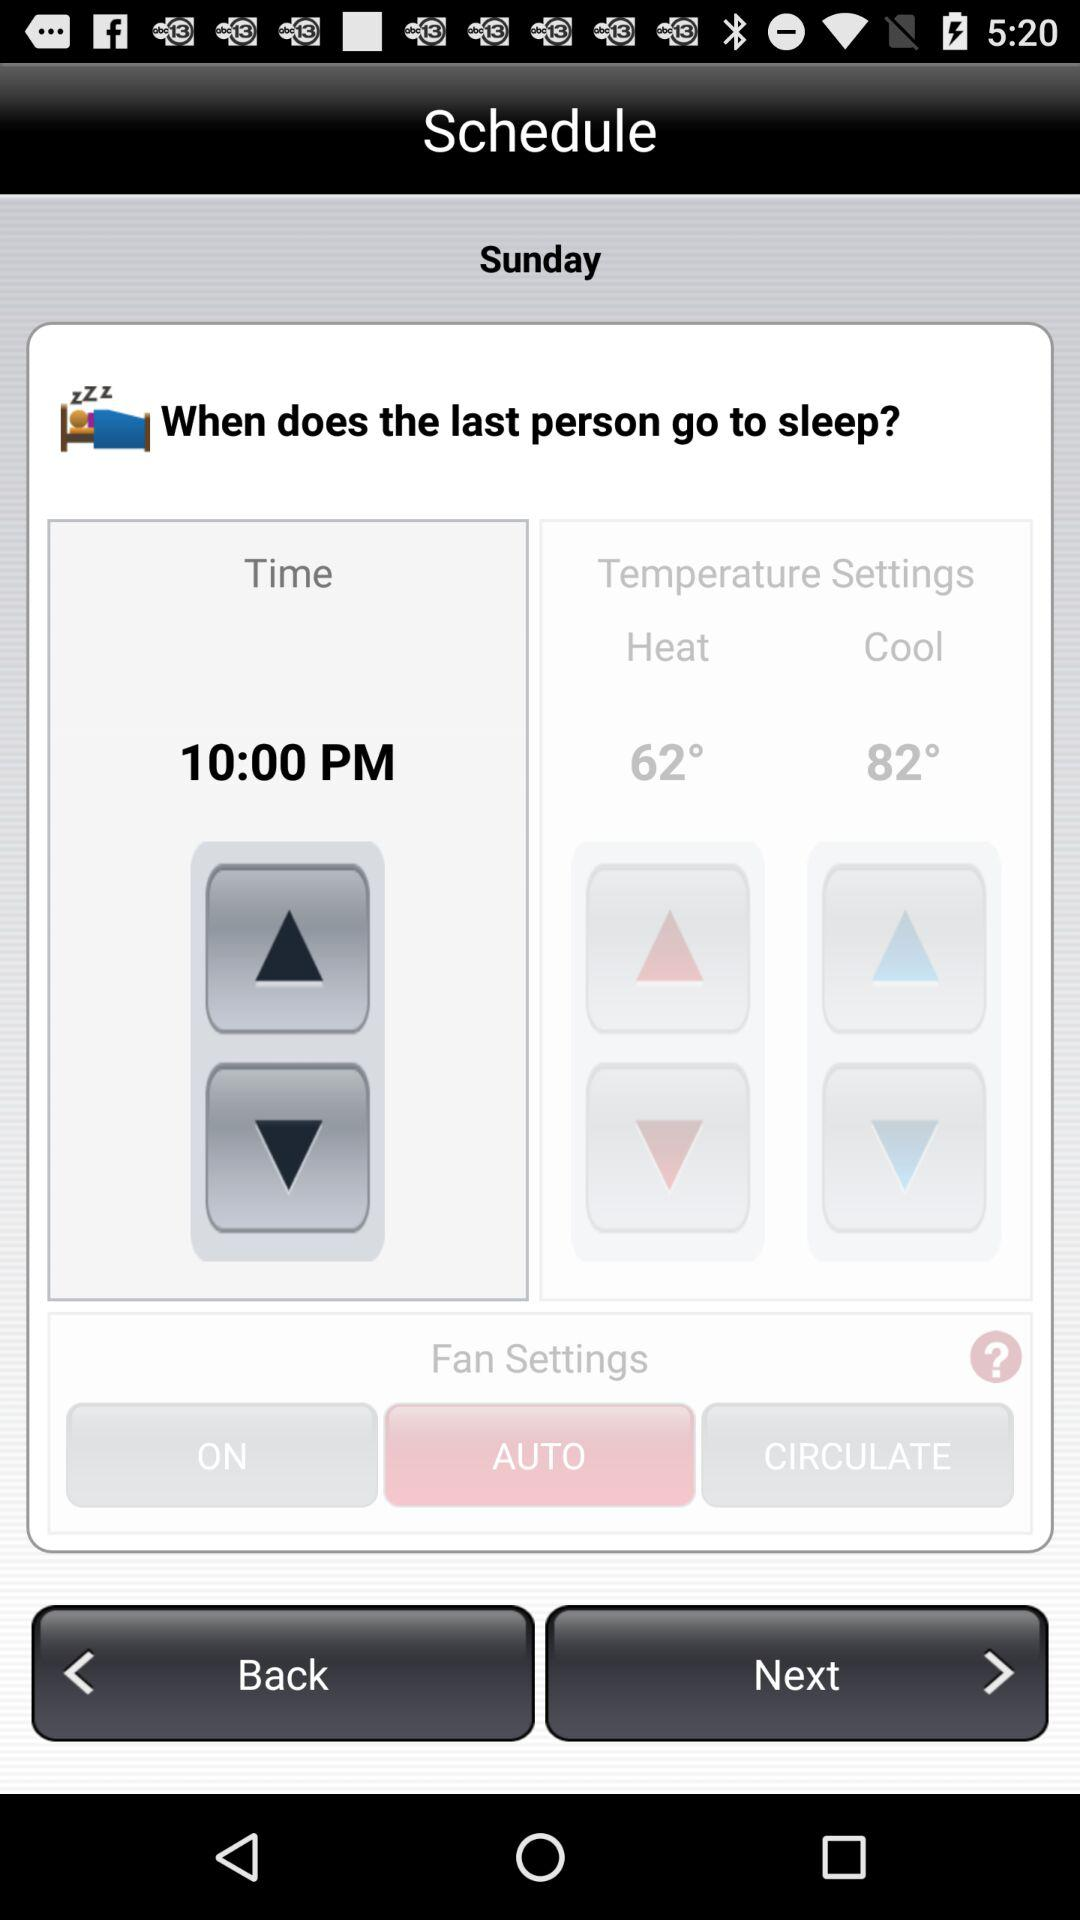What is the cold temperature? The cold temperature is 82°. 